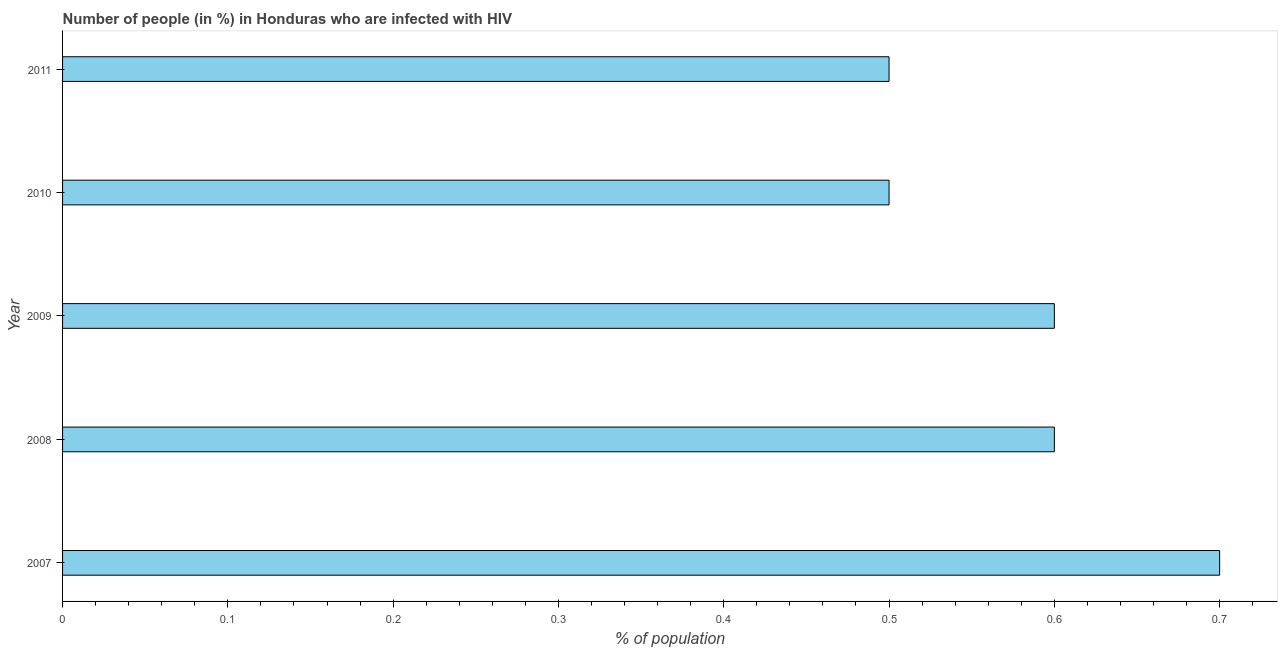What is the title of the graph?
Keep it short and to the point. Number of people (in %) in Honduras who are infected with HIV. What is the label or title of the X-axis?
Ensure brevity in your answer.  % of population. What is the label or title of the Y-axis?
Make the answer very short. Year. What is the number of people infected with hiv in 2010?
Your response must be concise. 0.5. Across all years, what is the minimum number of people infected with hiv?
Keep it short and to the point. 0.5. In which year was the number of people infected with hiv maximum?
Give a very brief answer. 2007. In which year was the number of people infected with hiv minimum?
Offer a terse response. 2010. What is the difference between the number of people infected with hiv in 2008 and 2011?
Give a very brief answer. 0.1. What is the average number of people infected with hiv per year?
Offer a terse response. 0.58. What is the median number of people infected with hiv?
Provide a succinct answer. 0.6. What is the ratio of the number of people infected with hiv in 2009 to that in 2011?
Your answer should be compact. 1.2. Is the difference between the number of people infected with hiv in 2007 and 2008 greater than the difference between any two years?
Offer a very short reply. No. What is the difference between the highest and the second highest number of people infected with hiv?
Give a very brief answer. 0.1. What is the difference between the highest and the lowest number of people infected with hiv?
Give a very brief answer. 0.2. In how many years, is the number of people infected with hiv greater than the average number of people infected with hiv taken over all years?
Your answer should be compact. 3. Are all the bars in the graph horizontal?
Provide a succinct answer. Yes. What is the difference between two consecutive major ticks on the X-axis?
Give a very brief answer. 0.1. Are the values on the major ticks of X-axis written in scientific E-notation?
Give a very brief answer. No. What is the % of population in 2009?
Offer a very short reply. 0.6. What is the % of population in 2010?
Offer a very short reply. 0.5. What is the % of population in 2011?
Ensure brevity in your answer.  0.5. What is the difference between the % of population in 2007 and 2009?
Keep it short and to the point. 0.1. What is the difference between the % of population in 2007 and 2010?
Keep it short and to the point. 0.2. What is the difference between the % of population in 2007 and 2011?
Offer a terse response. 0.2. What is the difference between the % of population in 2008 and 2009?
Provide a short and direct response. 0. What is the difference between the % of population in 2009 and 2010?
Provide a short and direct response. 0.1. What is the difference between the % of population in 2009 and 2011?
Give a very brief answer. 0.1. What is the difference between the % of population in 2010 and 2011?
Give a very brief answer. 0. What is the ratio of the % of population in 2007 to that in 2008?
Offer a terse response. 1.17. What is the ratio of the % of population in 2007 to that in 2009?
Your answer should be very brief. 1.17. What is the ratio of the % of population in 2007 to that in 2011?
Keep it short and to the point. 1.4. What is the ratio of the % of population in 2008 to that in 2009?
Offer a very short reply. 1. What is the ratio of the % of population in 2008 to that in 2011?
Offer a very short reply. 1.2. What is the ratio of the % of population in 2009 to that in 2010?
Offer a very short reply. 1.2. 